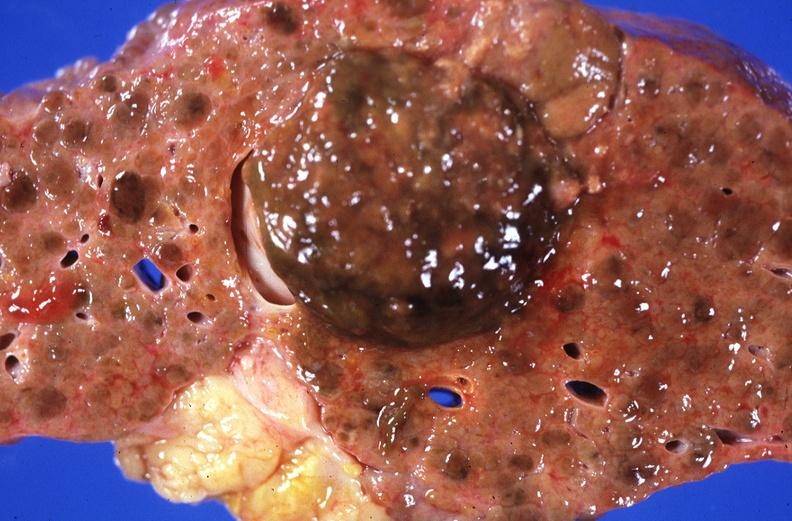does lesion in dome of uterus show hepatitis b virus, hepatocellular carcinoma?
Answer the question using a single word or phrase. No 